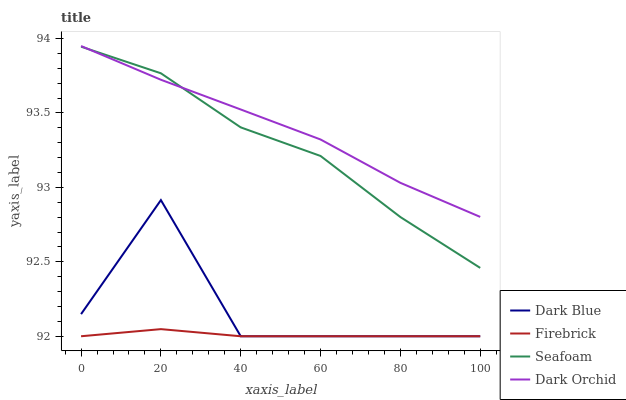Does Seafoam have the minimum area under the curve?
Answer yes or no. No. Does Seafoam have the maximum area under the curve?
Answer yes or no. No. Is Seafoam the smoothest?
Answer yes or no. No. Is Seafoam the roughest?
Answer yes or no. No. Does Seafoam have the lowest value?
Answer yes or no. No. Does Seafoam have the highest value?
Answer yes or no. No. Is Dark Blue less than Dark Orchid?
Answer yes or no. Yes. Is Dark Orchid greater than Firebrick?
Answer yes or no. Yes. Does Dark Blue intersect Dark Orchid?
Answer yes or no. No. 